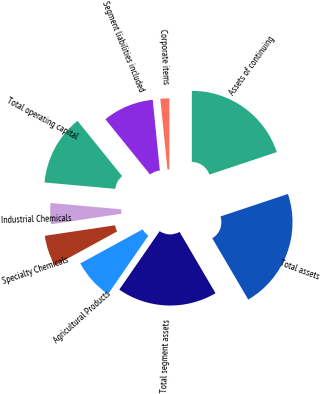<chart> <loc_0><loc_0><loc_500><loc_500><pie_chart><fcel>Agricultural Products<fcel>Specialty Chemicals<fcel>Industrial Chemicals<fcel>Total operating capital<fcel>Segment liabilities included<fcel>Corporate items<fcel>Assets of continuing<fcel>Total assets<fcel>Total segment assets<nl><fcel>7.41%<fcel>5.6%<fcel>3.8%<fcel>12.75%<fcel>9.22%<fcel>1.61%<fcel>19.87%<fcel>21.68%<fcel>18.07%<nl></chart> 